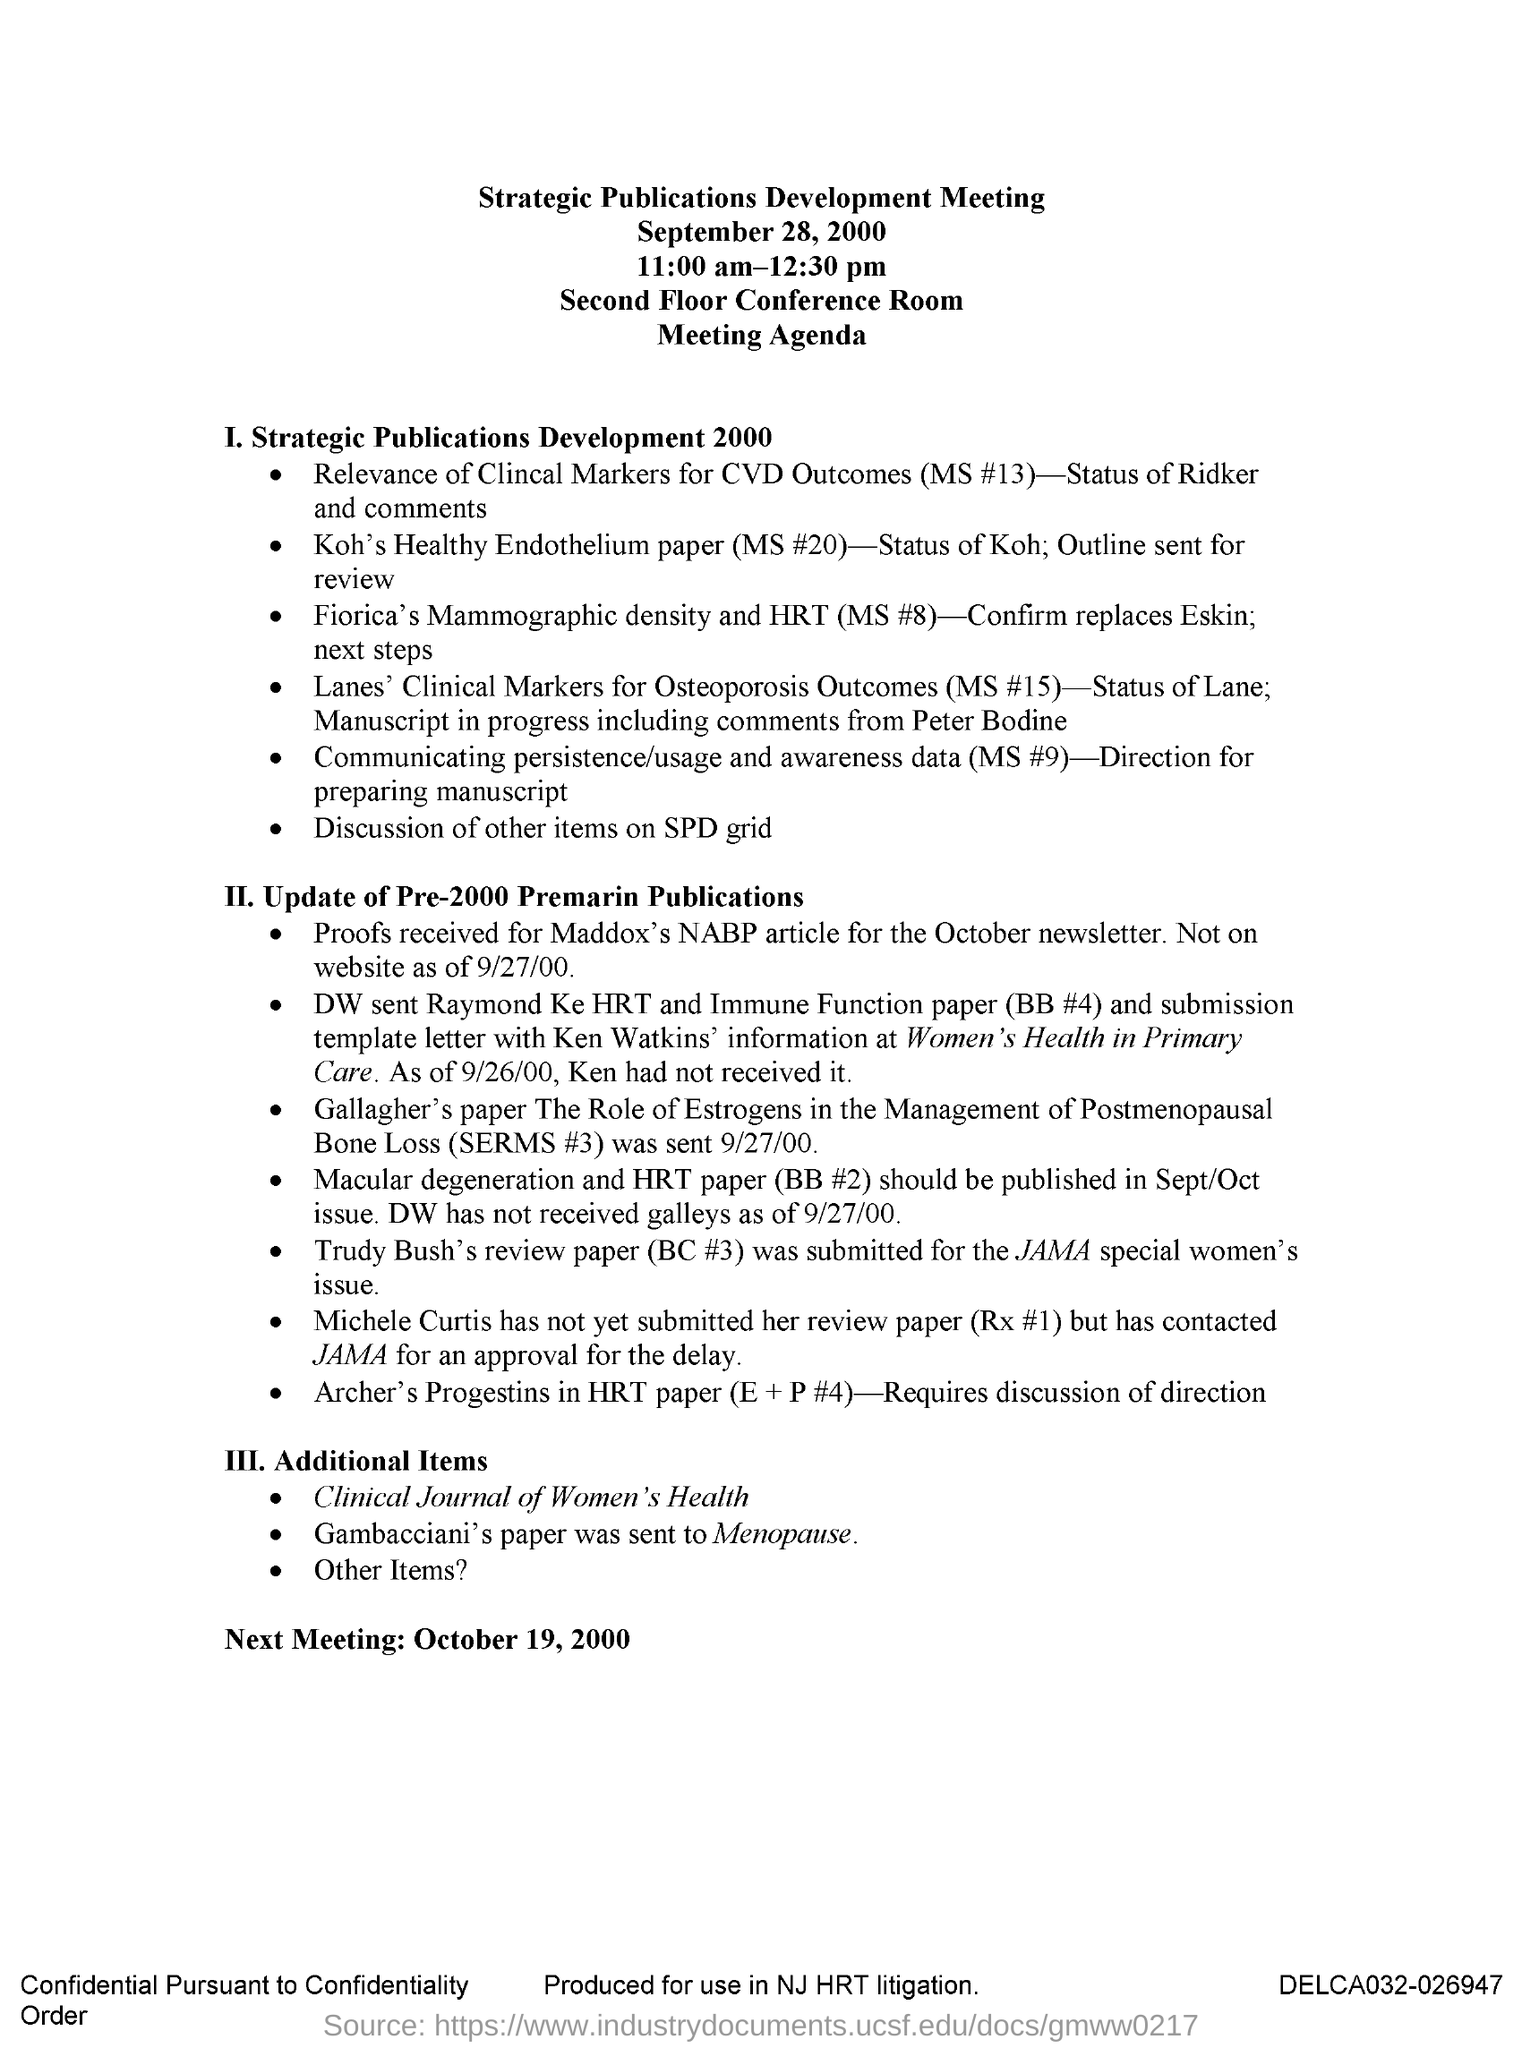Indicate a few pertinent items in this graphic. The Strategic Publications Development Meeting was held on September 28, 2000. The next meeting will be held on October 19, 2000. The Strategic Publications Development Meeting is held in the Second Floor Conference Room. The Strategic Publications Development Meeting is held from 11:00 am to 12:30 pm. 